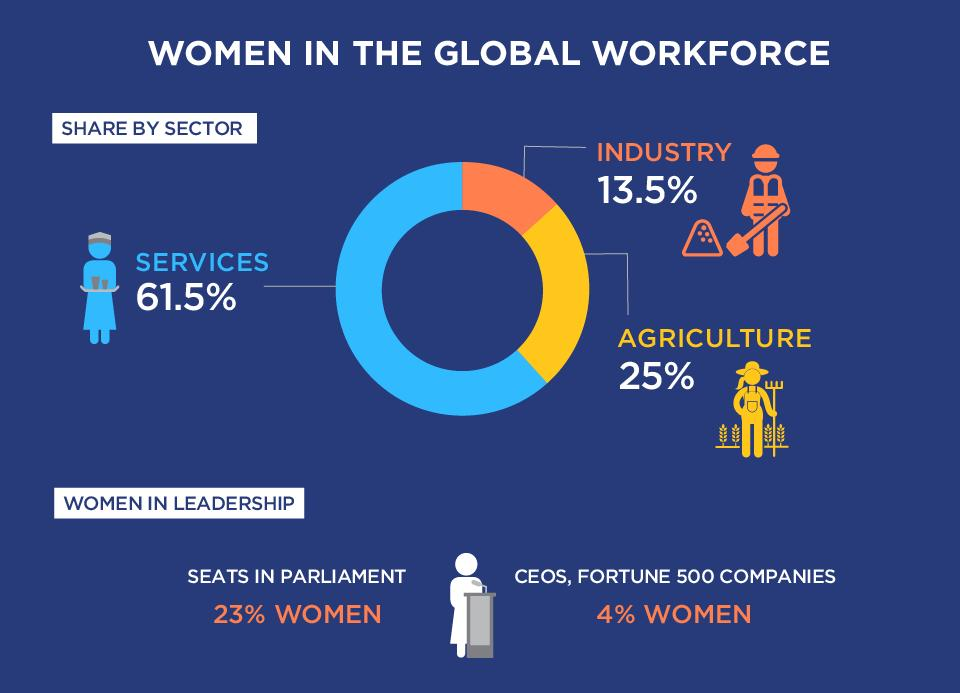Point out several critical features in this image. The percentage difference in the number of women working in services and industries is 48%. According to the data, the agricultural sector has the second highest percentage of women, followed by the education sector. According to a recent survey of Fortune 500 companies, only 4% of women hold leadership positions. 